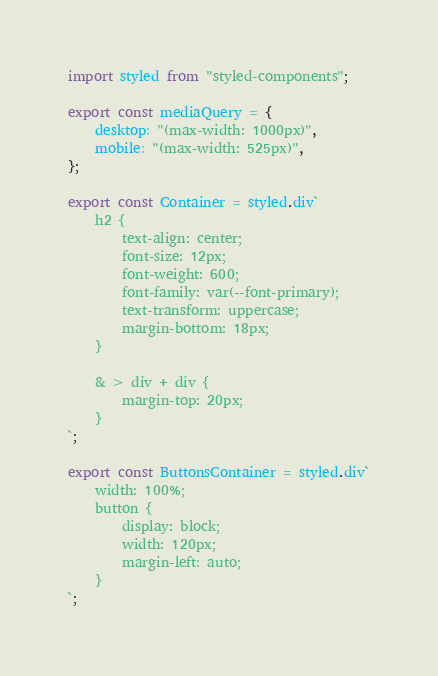Convert code to text. <code><loc_0><loc_0><loc_500><loc_500><_TypeScript_>import styled from "styled-components";

export const mediaQuery = {
    desktop: "(max-width: 1000px)",
    mobile: "(max-width: 525px)",
};

export const Container = styled.div`
    h2 {
        text-align: center;
        font-size: 12px;
        font-weight: 600;
        font-family: var(--font-primary);
        text-transform: uppercase;
        margin-bottom: 18px;
    }

    & > div + div {
        margin-top: 20px;
    }
`;

export const ButtonsContainer = styled.div`
    width: 100%;
    button {
        display: block;
        width: 120px;
        margin-left: auto;
    }
`;
</code> 